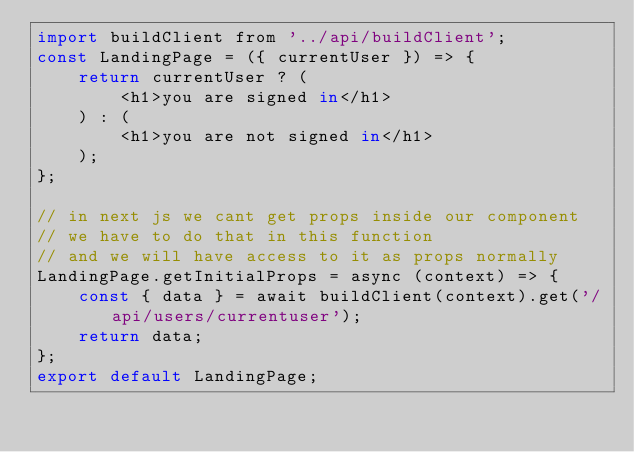Convert code to text. <code><loc_0><loc_0><loc_500><loc_500><_JavaScript_>import buildClient from '../api/buildClient';
const LandingPage = ({ currentUser }) => {
	return currentUser ? (
		<h1>you are signed in</h1>
	) : (
		<h1>you are not signed in</h1>
	);
};

// in next js we cant get props inside our component
// we have to do that in this function
// and we will have access to it as props normally
LandingPage.getInitialProps = async (context) => {
	const { data } = await buildClient(context).get('/api/users/currentuser');
	return data;
};
export default LandingPage;
</code> 